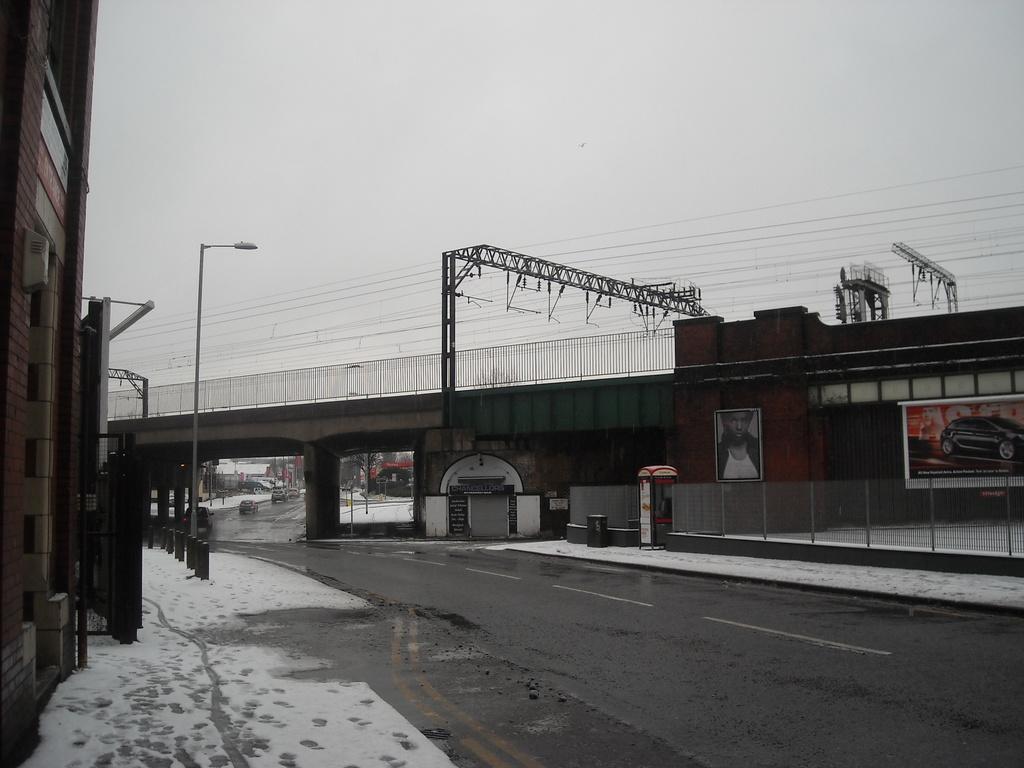Could you give a brief overview of what you see in this image? In this picture there is a bridge and there are poles in the center. On the left side there is a building. On the right side of the wall there are banners and there is a fence. In the background there are cars on the road and the sky is cloudy. 